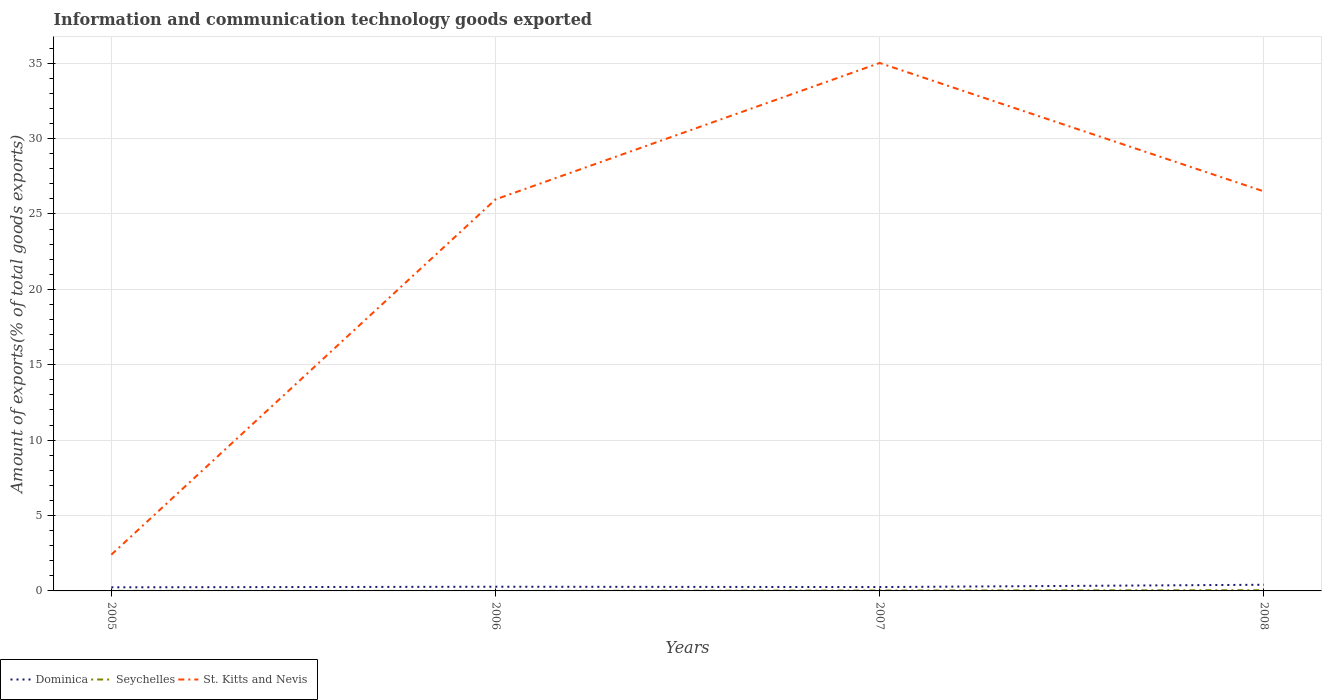How many different coloured lines are there?
Offer a very short reply. 3. Does the line corresponding to Dominica intersect with the line corresponding to St. Kitts and Nevis?
Offer a terse response. No. Across all years, what is the maximum amount of goods exported in Dominica?
Make the answer very short. 0.24. In which year was the amount of goods exported in Seychelles maximum?
Provide a short and direct response. 2006. What is the total amount of goods exported in Seychelles in the graph?
Provide a succinct answer. -0.02. What is the difference between the highest and the second highest amount of goods exported in Seychelles?
Provide a short and direct response. 0.05. Is the amount of goods exported in Seychelles strictly greater than the amount of goods exported in St. Kitts and Nevis over the years?
Ensure brevity in your answer.  Yes. How many lines are there?
Your answer should be compact. 3. How many years are there in the graph?
Provide a short and direct response. 4. What is the difference between two consecutive major ticks on the Y-axis?
Give a very brief answer. 5. Does the graph contain any zero values?
Offer a terse response. No. Does the graph contain grids?
Offer a terse response. Yes. Where does the legend appear in the graph?
Offer a terse response. Bottom left. What is the title of the graph?
Provide a short and direct response. Information and communication technology goods exported. What is the label or title of the X-axis?
Your answer should be compact. Years. What is the label or title of the Y-axis?
Make the answer very short. Amount of exports(% of total goods exports). What is the Amount of exports(% of total goods exports) of Dominica in 2005?
Provide a succinct answer. 0.24. What is the Amount of exports(% of total goods exports) of Seychelles in 2005?
Offer a terse response. 0.01. What is the Amount of exports(% of total goods exports) in St. Kitts and Nevis in 2005?
Keep it short and to the point. 2.4. What is the Amount of exports(% of total goods exports) in Dominica in 2006?
Your answer should be very brief. 0.28. What is the Amount of exports(% of total goods exports) in Seychelles in 2006?
Make the answer very short. 0. What is the Amount of exports(% of total goods exports) in St. Kitts and Nevis in 2006?
Provide a short and direct response. 25.97. What is the Amount of exports(% of total goods exports) of Dominica in 2007?
Keep it short and to the point. 0.26. What is the Amount of exports(% of total goods exports) in Seychelles in 2007?
Your answer should be very brief. 0.03. What is the Amount of exports(% of total goods exports) in St. Kitts and Nevis in 2007?
Your response must be concise. 35.02. What is the Amount of exports(% of total goods exports) in Dominica in 2008?
Ensure brevity in your answer.  0.41. What is the Amount of exports(% of total goods exports) of Seychelles in 2008?
Your answer should be compact. 0.05. What is the Amount of exports(% of total goods exports) of St. Kitts and Nevis in 2008?
Keep it short and to the point. 26.5. Across all years, what is the maximum Amount of exports(% of total goods exports) of Dominica?
Ensure brevity in your answer.  0.41. Across all years, what is the maximum Amount of exports(% of total goods exports) of Seychelles?
Offer a terse response. 0.05. Across all years, what is the maximum Amount of exports(% of total goods exports) in St. Kitts and Nevis?
Ensure brevity in your answer.  35.02. Across all years, what is the minimum Amount of exports(% of total goods exports) in Dominica?
Ensure brevity in your answer.  0.24. Across all years, what is the minimum Amount of exports(% of total goods exports) in Seychelles?
Provide a succinct answer. 0. Across all years, what is the minimum Amount of exports(% of total goods exports) in St. Kitts and Nevis?
Provide a short and direct response. 2.4. What is the total Amount of exports(% of total goods exports) of Dominica in the graph?
Offer a very short reply. 1.18. What is the total Amount of exports(% of total goods exports) in Seychelles in the graph?
Keep it short and to the point. 0.08. What is the total Amount of exports(% of total goods exports) in St. Kitts and Nevis in the graph?
Offer a terse response. 89.89. What is the difference between the Amount of exports(% of total goods exports) of Dominica in 2005 and that in 2006?
Offer a terse response. -0.04. What is the difference between the Amount of exports(% of total goods exports) of Seychelles in 2005 and that in 2006?
Provide a succinct answer. 0. What is the difference between the Amount of exports(% of total goods exports) of St. Kitts and Nevis in 2005 and that in 2006?
Make the answer very short. -23.56. What is the difference between the Amount of exports(% of total goods exports) of Dominica in 2005 and that in 2007?
Keep it short and to the point. -0.02. What is the difference between the Amount of exports(% of total goods exports) in Seychelles in 2005 and that in 2007?
Your answer should be compact. -0.02. What is the difference between the Amount of exports(% of total goods exports) in St. Kitts and Nevis in 2005 and that in 2007?
Offer a very short reply. -32.61. What is the difference between the Amount of exports(% of total goods exports) in Dominica in 2005 and that in 2008?
Keep it short and to the point. -0.17. What is the difference between the Amount of exports(% of total goods exports) of Seychelles in 2005 and that in 2008?
Provide a succinct answer. -0.04. What is the difference between the Amount of exports(% of total goods exports) of St. Kitts and Nevis in 2005 and that in 2008?
Your answer should be compact. -24.09. What is the difference between the Amount of exports(% of total goods exports) of Dominica in 2006 and that in 2007?
Your response must be concise. 0.02. What is the difference between the Amount of exports(% of total goods exports) in Seychelles in 2006 and that in 2007?
Provide a short and direct response. -0.03. What is the difference between the Amount of exports(% of total goods exports) in St. Kitts and Nevis in 2006 and that in 2007?
Provide a succinct answer. -9.05. What is the difference between the Amount of exports(% of total goods exports) in Dominica in 2006 and that in 2008?
Offer a terse response. -0.13. What is the difference between the Amount of exports(% of total goods exports) of Seychelles in 2006 and that in 2008?
Provide a succinct answer. -0.05. What is the difference between the Amount of exports(% of total goods exports) of St. Kitts and Nevis in 2006 and that in 2008?
Offer a terse response. -0.53. What is the difference between the Amount of exports(% of total goods exports) in Dominica in 2007 and that in 2008?
Make the answer very short. -0.15. What is the difference between the Amount of exports(% of total goods exports) in Seychelles in 2007 and that in 2008?
Give a very brief answer. -0.02. What is the difference between the Amount of exports(% of total goods exports) in St. Kitts and Nevis in 2007 and that in 2008?
Keep it short and to the point. 8.52. What is the difference between the Amount of exports(% of total goods exports) in Dominica in 2005 and the Amount of exports(% of total goods exports) in Seychelles in 2006?
Provide a succinct answer. 0.24. What is the difference between the Amount of exports(% of total goods exports) of Dominica in 2005 and the Amount of exports(% of total goods exports) of St. Kitts and Nevis in 2006?
Your answer should be very brief. -25.73. What is the difference between the Amount of exports(% of total goods exports) of Seychelles in 2005 and the Amount of exports(% of total goods exports) of St. Kitts and Nevis in 2006?
Ensure brevity in your answer.  -25.96. What is the difference between the Amount of exports(% of total goods exports) of Dominica in 2005 and the Amount of exports(% of total goods exports) of Seychelles in 2007?
Make the answer very short. 0.21. What is the difference between the Amount of exports(% of total goods exports) of Dominica in 2005 and the Amount of exports(% of total goods exports) of St. Kitts and Nevis in 2007?
Keep it short and to the point. -34.78. What is the difference between the Amount of exports(% of total goods exports) of Seychelles in 2005 and the Amount of exports(% of total goods exports) of St. Kitts and Nevis in 2007?
Offer a very short reply. -35.01. What is the difference between the Amount of exports(% of total goods exports) of Dominica in 2005 and the Amount of exports(% of total goods exports) of Seychelles in 2008?
Offer a very short reply. 0.19. What is the difference between the Amount of exports(% of total goods exports) of Dominica in 2005 and the Amount of exports(% of total goods exports) of St. Kitts and Nevis in 2008?
Offer a terse response. -26.26. What is the difference between the Amount of exports(% of total goods exports) in Seychelles in 2005 and the Amount of exports(% of total goods exports) in St. Kitts and Nevis in 2008?
Give a very brief answer. -26.49. What is the difference between the Amount of exports(% of total goods exports) in Dominica in 2006 and the Amount of exports(% of total goods exports) in Seychelles in 2007?
Your answer should be very brief. 0.25. What is the difference between the Amount of exports(% of total goods exports) of Dominica in 2006 and the Amount of exports(% of total goods exports) of St. Kitts and Nevis in 2007?
Provide a succinct answer. -34.74. What is the difference between the Amount of exports(% of total goods exports) in Seychelles in 2006 and the Amount of exports(% of total goods exports) in St. Kitts and Nevis in 2007?
Keep it short and to the point. -35.02. What is the difference between the Amount of exports(% of total goods exports) in Dominica in 2006 and the Amount of exports(% of total goods exports) in Seychelles in 2008?
Your response must be concise. 0.23. What is the difference between the Amount of exports(% of total goods exports) of Dominica in 2006 and the Amount of exports(% of total goods exports) of St. Kitts and Nevis in 2008?
Your answer should be very brief. -26.22. What is the difference between the Amount of exports(% of total goods exports) of Seychelles in 2006 and the Amount of exports(% of total goods exports) of St. Kitts and Nevis in 2008?
Offer a terse response. -26.5. What is the difference between the Amount of exports(% of total goods exports) of Dominica in 2007 and the Amount of exports(% of total goods exports) of Seychelles in 2008?
Your response must be concise. 0.21. What is the difference between the Amount of exports(% of total goods exports) of Dominica in 2007 and the Amount of exports(% of total goods exports) of St. Kitts and Nevis in 2008?
Your answer should be very brief. -26.24. What is the difference between the Amount of exports(% of total goods exports) of Seychelles in 2007 and the Amount of exports(% of total goods exports) of St. Kitts and Nevis in 2008?
Your answer should be compact. -26.47. What is the average Amount of exports(% of total goods exports) in Dominica per year?
Your answer should be very brief. 0.3. What is the average Amount of exports(% of total goods exports) of Seychelles per year?
Give a very brief answer. 0.02. What is the average Amount of exports(% of total goods exports) in St. Kitts and Nevis per year?
Your answer should be compact. 22.47. In the year 2005, what is the difference between the Amount of exports(% of total goods exports) of Dominica and Amount of exports(% of total goods exports) of Seychelles?
Offer a terse response. 0.23. In the year 2005, what is the difference between the Amount of exports(% of total goods exports) of Dominica and Amount of exports(% of total goods exports) of St. Kitts and Nevis?
Your response must be concise. -2.17. In the year 2005, what is the difference between the Amount of exports(% of total goods exports) in Seychelles and Amount of exports(% of total goods exports) in St. Kitts and Nevis?
Provide a short and direct response. -2.4. In the year 2006, what is the difference between the Amount of exports(% of total goods exports) of Dominica and Amount of exports(% of total goods exports) of Seychelles?
Your answer should be compact. 0.28. In the year 2006, what is the difference between the Amount of exports(% of total goods exports) of Dominica and Amount of exports(% of total goods exports) of St. Kitts and Nevis?
Keep it short and to the point. -25.69. In the year 2006, what is the difference between the Amount of exports(% of total goods exports) in Seychelles and Amount of exports(% of total goods exports) in St. Kitts and Nevis?
Offer a very short reply. -25.96. In the year 2007, what is the difference between the Amount of exports(% of total goods exports) in Dominica and Amount of exports(% of total goods exports) in Seychelles?
Provide a short and direct response. 0.23. In the year 2007, what is the difference between the Amount of exports(% of total goods exports) in Dominica and Amount of exports(% of total goods exports) in St. Kitts and Nevis?
Ensure brevity in your answer.  -34.76. In the year 2007, what is the difference between the Amount of exports(% of total goods exports) of Seychelles and Amount of exports(% of total goods exports) of St. Kitts and Nevis?
Offer a terse response. -34.99. In the year 2008, what is the difference between the Amount of exports(% of total goods exports) in Dominica and Amount of exports(% of total goods exports) in Seychelles?
Offer a terse response. 0.36. In the year 2008, what is the difference between the Amount of exports(% of total goods exports) in Dominica and Amount of exports(% of total goods exports) in St. Kitts and Nevis?
Keep it short and to the point. -26.09. In the year 2008, what is the difference between the Amount of exports(% of total goods exports) in Seychelles and Amount of exports(% of total goods exports) in St. Kitts and Nevis?
Your answer should be very brief. -26.45. What is the ratio of the Amount of exports(% of total goods exports) of Dominica in 2005 to that in 2006?
Your answer should be very brief. 0.86. What is the ratio of the Amount of exports(% of total goods exports) of Seychelles in 2005 to that in 2006?
Your answer should be very brief. 4.97. What is the ratio of the Amount of exports(% of total goods exports) in St. Kitts and Nevis in 2005 to that in 2006?
Your answer should be very brief. 0.09. What is the ratio of the Amount of exports(% of total goods exports) of Dominica in 2005 to that in 2007?
Offer a terse response. 0.93. What is the ratio of the Amount of exports(% of total goods exports) in Seychelles in 2005 to that in 2007?
Provide a short and direct response. 0.2. What is the ratio of the Amount of exports(% of total goods exports) in St. Kitts and Nevis in 2005 to that in 2007?
Provide a succinct answer. 0.07. What is the ratio of the Amount of exports(% of total goods exports) of Dominica in 2005 to that in 2008?
Provide a succinct answer. 0.58. What is the ratio of the Amount of exports(% of total goods exports) of Seychelles in 2005 to that in 2008?
Offer a very short reply. 0.12. What is the ratio of the Amount of exports(% of total goods exports) in St. Kitts and Nevis in 2005 to that in 2008?
Make the answer very short. 0.09. What is the ratio of the Amount of exports(% of total goods exports) in Dominica in 2006 to that in 2007?
Your answer should be very brief. 1.08. What is the ratio of the Amount of exports(% of total goods exports) of Seychelles in 2006 to that in 2007?
Provide a short and direct response. 0.04. What is the ratio of the Amount of exports(% of total goods exports) of St. Kitts and Nevis in 2006 to that in 2007?
Keep it short and to the point. 0.74. What is the ratio of the Amount of exports(% of total goods exports) of Dominica in 2006 to that in 2008?
Your answer should be compact. 0.68. What is the ratio of the Amount of exports(% of total goods exports) of Seychelles in 2006 to that in 2008?
Ensure brevity in your answer.  0.02. What is the ratio of the Amount of exports(% of total goods exports) in St. Kitts and Nevis in 2006 to that in 2008?
Your answer should be very brief. 0.98. What is the ratio of the Amount of exports(% of total goods exports) in Dominica in 2007 to that in 2008?
Offer a very short reply. 0.63. What is the ratio of the Amount of exports(% of total goods exports) of Seychelles in 2007 to that in 2008?
Give a very brief answer. 0.59. What is the ratio of the Amount of exports(% of total goods exports) in St. Kitts and Nevis in 2007 to that in 2008?
Give a very brief answer. 1.32. What is the difference between the highest and the second highest Amount of exports(% of total goods exports) in Dominica?
Give a very brief answer. 0.13. What is the difference between the highest and the second highest Amount of exports(% of total goods exports) of Seychelles?
Offer a very short reply. 0.02. What is the difference between the highest and the second highest Amount of exports(% of total goods exports) in St. Kitts and Nevis?
Your answer should be very brief. 8.52. What is the difference between the highest and the lowest Amount of exports(% of total goods exports) in Dominica?
Make the answer very short. 0.17. What is the difference between the highest and the lowest Amount of exports(% of total goods exports) of Seychelles?
Provide a short and direct response. 0.05. What is the difference between the highest and the lowest Amount of exports(% of total goods exports) in St. Kitts and Nevis?
Keep it short and to the point. 32.61. 